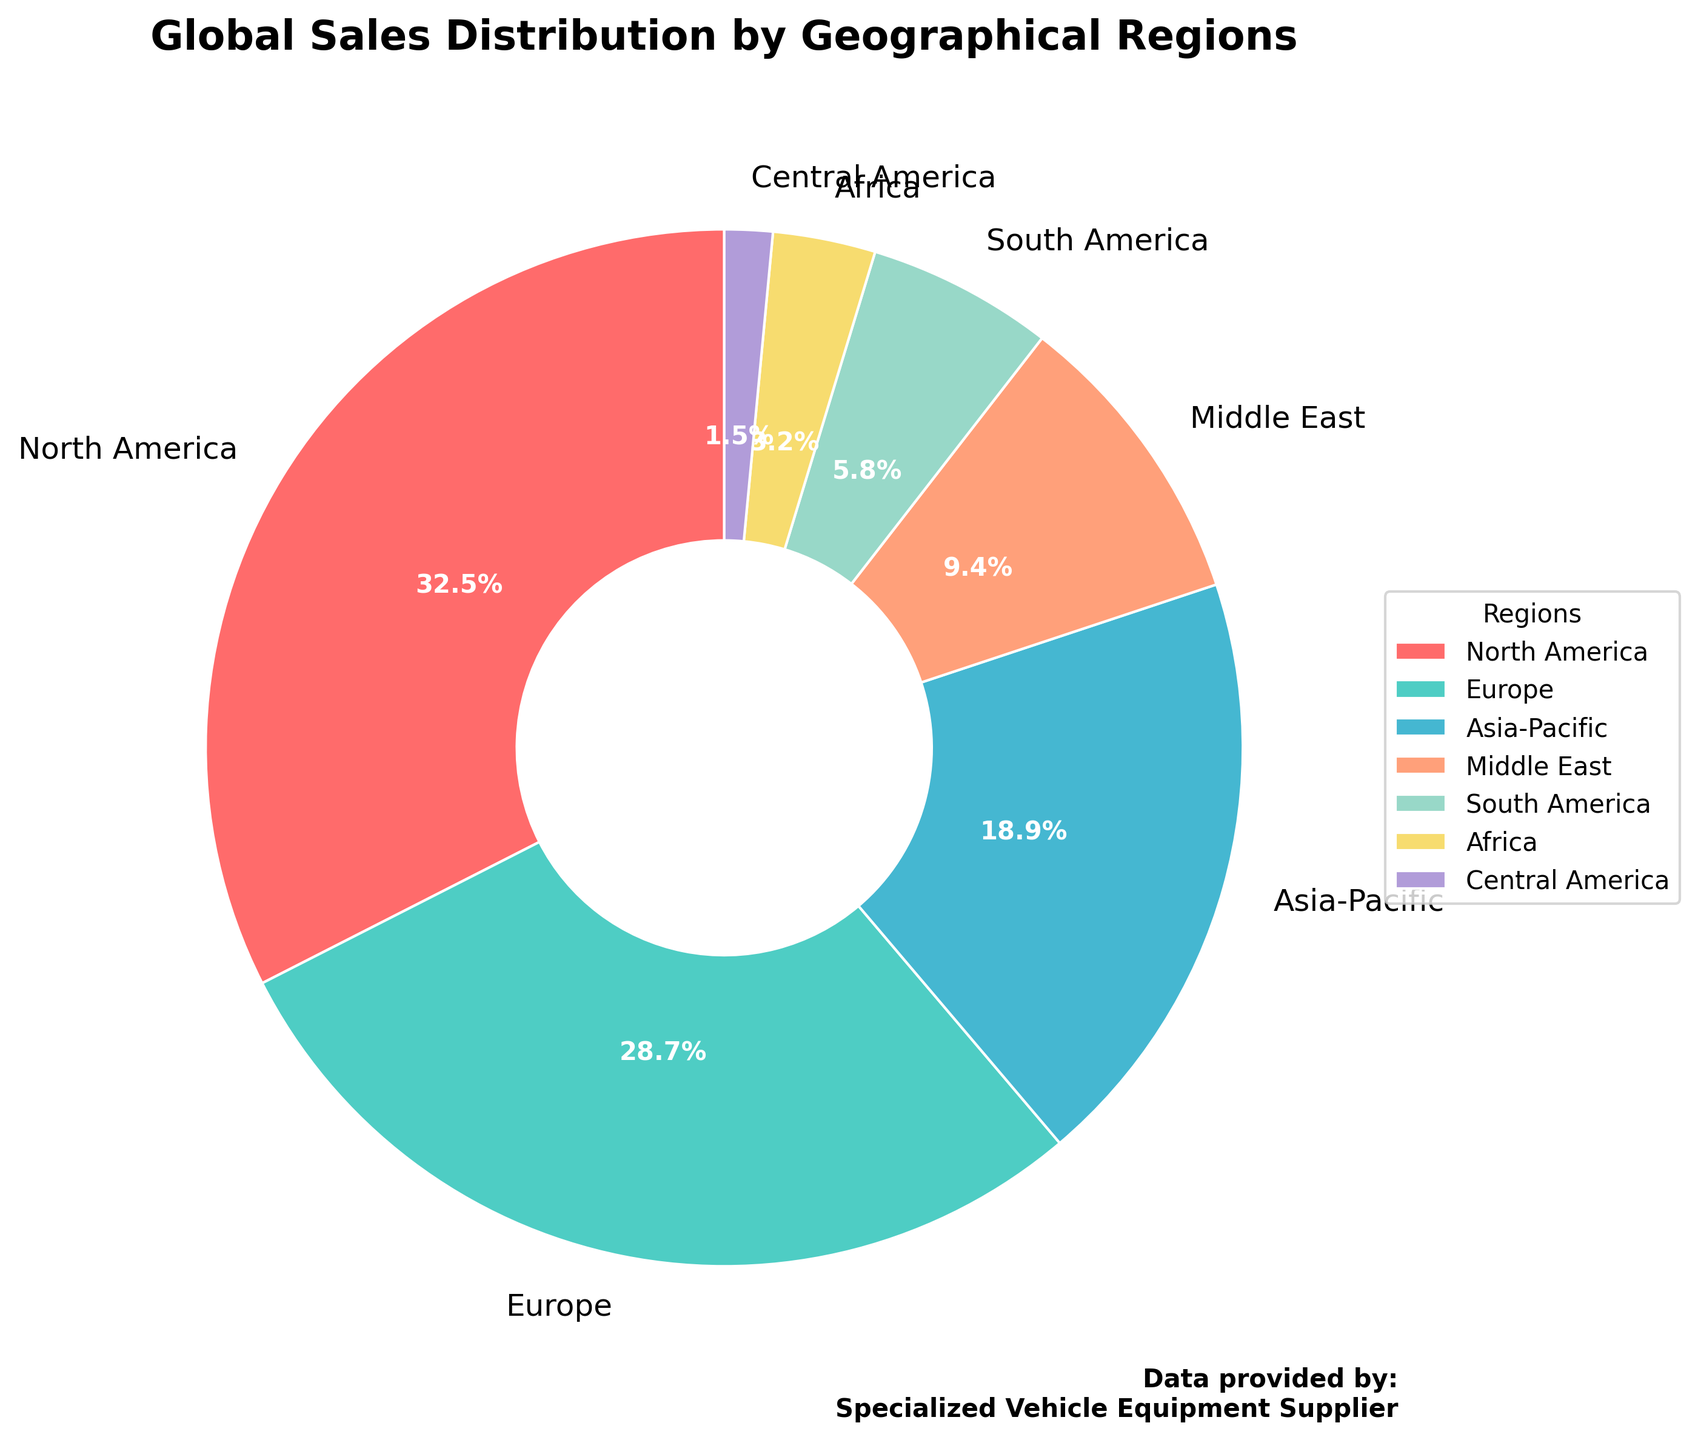What percentage of global sales does North America contribute? North America's percentage is directly labeled on the chart as 32.5%.
Answer: 32.5% Which region has the second-highest sales percentage? By observing the chart, Europe is the region with the second-highest percentage after North America, labeled as 28.7%.
Answer: Europe Are the combined sales percentages of Africa and Central America less than South America? Africa has 3.2% and Central America has 1.5%, so combined, they have 3.2 + 1.5 = 4.7%. South America has a sales percentage of 5.8%, which is greater than 4.7%.
Answer: Yes How much larger is North America's sales percentage compared to Asia-Pacific's? North America has 32.5%, and Asia-Pacific has 18.9%. The difference is 32.5 - 18.9 = 13.6%.
Answer: 13.6% What is the total sales percentage of the three regions with the smallest contributions to global sales? The three regions with the smallest contributions are Africa (3.2%), Central America (1.5%), and South America (5.8%). Their combined total is 3.2 + 1.5 + 5.8 = 10.5%.
Answer: 10.5% Which region is represented by the largest wedge in the pie chart? The largest wedge corresponds to North America, which has the highest sales percentage of 32.5%.
Answer: North America How does the sales percentage of the Middle East compare to that of Europe? The Middle East has 9.4% and Europe has 28.7%. Europe’s sales percentage is significantly higher than that of the Middle East.
Answer: Europe's percentage is higher What is the visual color associated with the region contributing the lowest sales percentage? Central America, contributing 1.5%, is associated with the color purple as per the wedge it is represented by.
Answer: Purple (or the color specific from the list) Sum the sales percentages of the regions in the southern hemisphere. The regions are South America (5.8%) and Africa (3.2%). Their combined total is 5.8 + 3.2 = 9%.
Answer: 9% Which region has a sales percentage closest to 10%? Middle East is labeled with 9.4%, which is the closest percentage to 10%.
Answer: Middle East 